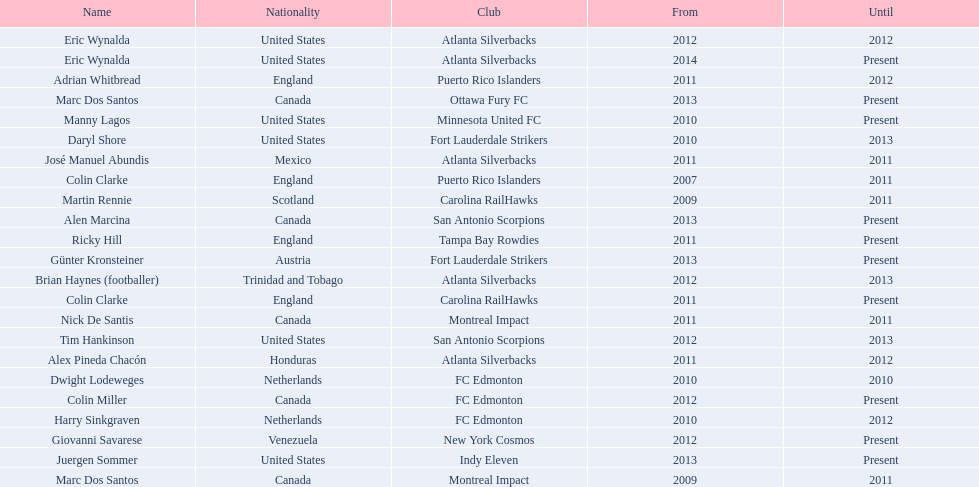What were all the coaches who were coaching in 2010? Martin Rennie, Dwight Lodeweges, Harry Sinkgraven, Daryl Shore, Manny Lagos, Marc Dos Santos, Colin Clarke. Which of the 2010 coaches were not born in north america? Martin Rennie, Dwight Lodeweges, Harry Sinkgraven, Colin Clarke. Which coaches that were coaching in 2010 and were not from north america did not coach for fc edmonton? Martin Rennie, Colin Clarke. What coach did not coach for fc edmonton in 2010 and was not north american nationality had the shortened career as a coach? Martin Rennie. 